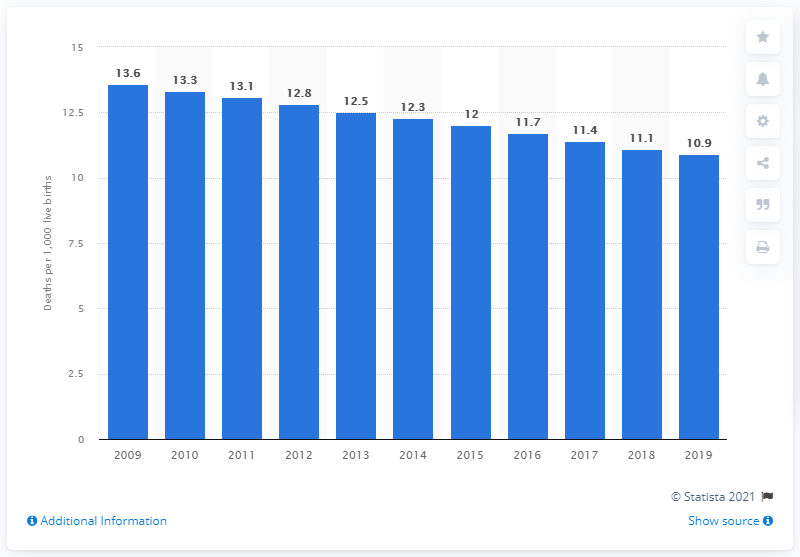Draw attention to some important aspects in this diagram. In 2019, the infant mortality rate in the Bahamas was 10.9 per 1,000 live births. 